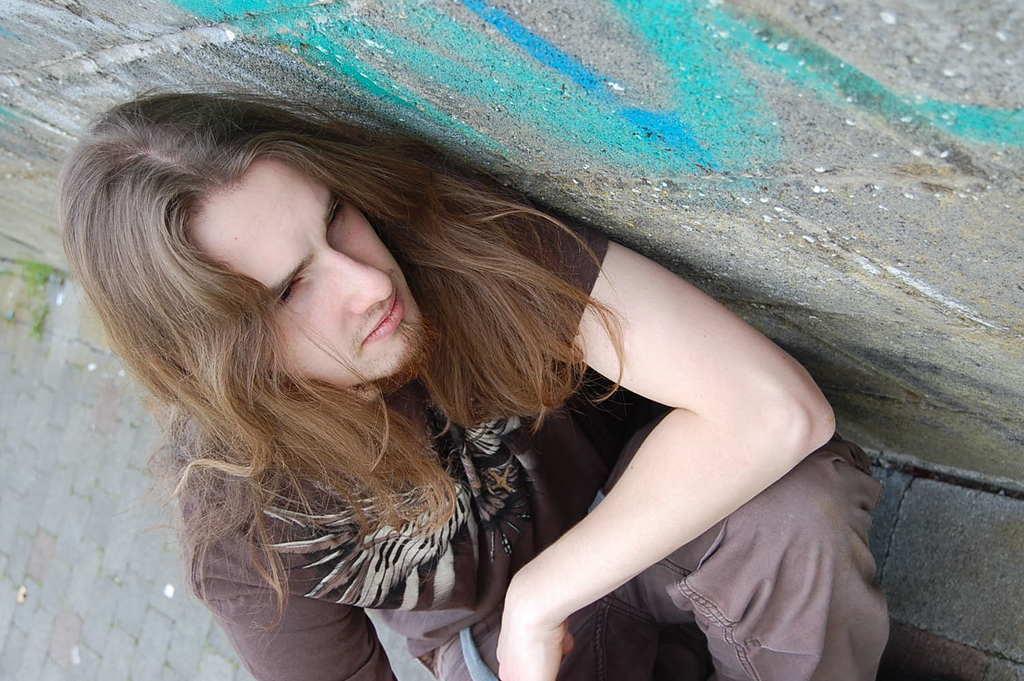Could you give a brief overview of what you see in this image? In this image we can see a person with a long hair. Beside the person we can see a wall. 